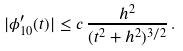<formula> <loc_0><loc_0><loc_500><loc_500>| \phi _ { 1 0 } ^ { \prime } ( t ) | \leq c \, \frac { h ^ { 2 } } { ( t ^ { 2 } + h ^ { 2 } ) ^ { 3 / 2 } } \, .</formula> 